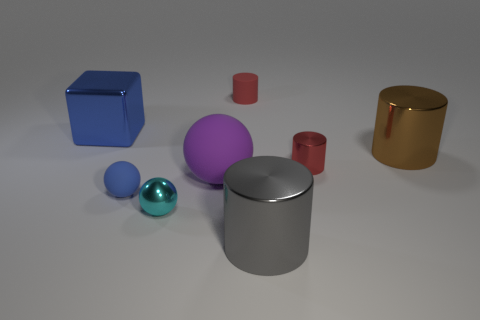Add 1 large blue metal cubes. How many objects exist? 9 Subtract all balls. How many objects are left? 5 Add 8 small spheres. How many small spheres exist? 10 Subtract 0 yellow spheres. How many objects are left? 8 Subtract all blue metallic blocks. Subtract all tiny matte balls. How many objects are left? 6 Add 2 tiny cyan shiny balls. How many tiny cyan shiny balls are left? 3 